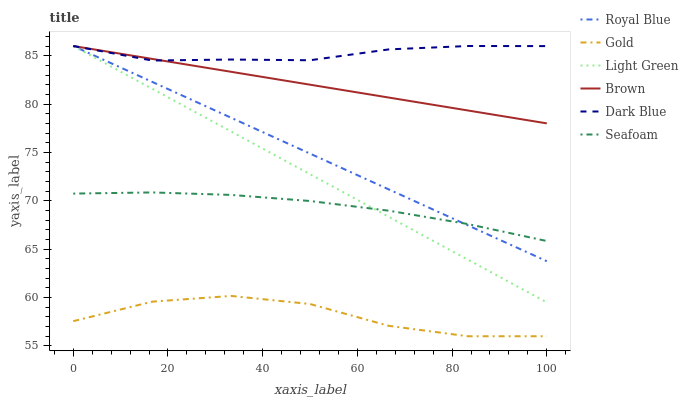Does Gold have the minimum area under the curve?
Answer yes or no. Yes. Does Dark Blue have the maximum area under the curve?
Answer yes or no. Yes. Does Dark Blue have the minimum area under the curve?
Answer yes or no. No. Does Gold have the maximum area under the curve?
Answer yes or no. No. Is Brown the smoothest?
Answer yes or no. Yes. Is Gold the roughest?
Answer yes or no. Yes. Is Dark Blue the smoothest?
Answer yes or no. No. Is Dark Blue the roughest?
Answer yes or no. No. Does Gold have the lowest value?
Answer yes or no. Yes. Does Dark Blue have the lowest value?
Answer yes or no. No. Does Light Green have the highest value?
Answer yes or no. Yes. Does Gold have the highest value?
Answer yes or no. No. Is Seafoam less than Brown?
Answer yes or no. Yes. Is Brown greater than Gold?
Answer yes or no. Yes. Does Royal Blue intersect Light Green?
Answer yes or no. Yes. Is Royal Blue less than Light Green?
Answer yes or no. No. Is Royal Blue greater than Light Green?
Answer yes or no. No. Does Seafoam intersect Brown?
Answer yes or no. No. 